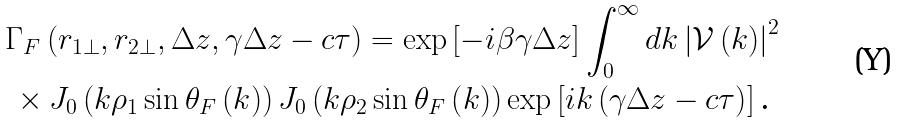Convert formula to latex. <formula><loc_0><loc_0><loc_500><loc_500>& \Gamma _ { F } \left ( r _ { 1 \bot } , r _ { 2 \bot } , \Delta z , \gamma \Delta z - c \tau \right ) = \exp \left [ - i \beta \gamma \Delta z \right ] \int _ { 0 } ^ { \infty } d k \left | \mathcal { V } \left ( k \right ) \right | ^ { 2 } \\ & \, \times J _ { 0 } \left ( k \rho _ { 1 } \sin \theta _ { F } \left ( k \right ) \right ) J _ { 0 } \left ( k \rho _ { 2 } \sin \theta _ { F } \left ( k \right ) \right ) \exp \left [ i k \left ( \gamma \Delta z - c \tau \right ) \right ] \text {.}</formula> 